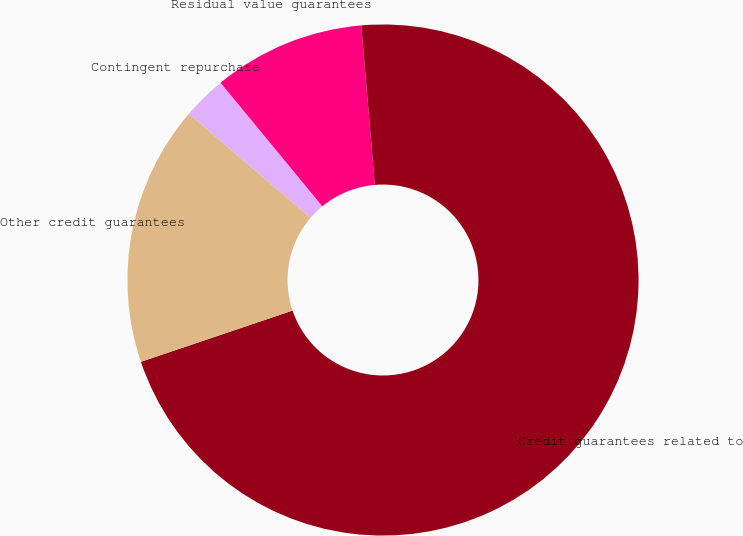<chart> <loc_0><loc_0><loc_500><loc_500><pie_chart><fcel>Contingent repurchase<fcel>Residual value guarantees<fcel>Credit guarantees related to<fcel>Other credit guarantees<nl><fcel>2.77%<fcel>9.61%<fcel>71.17%<fcel>16.45%<nl></chart> 